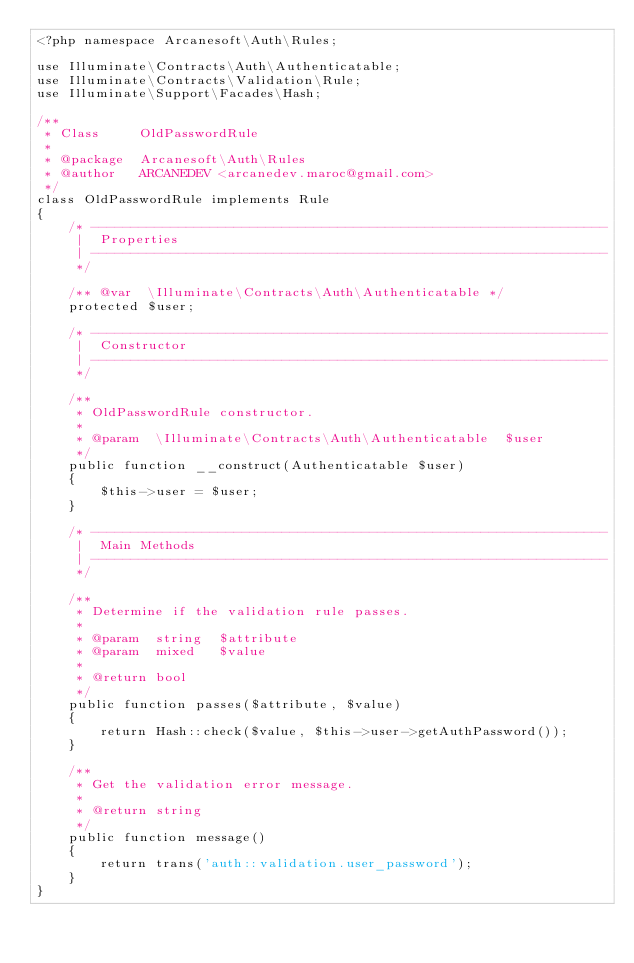<code> <loc_0><loc_0><loc_500><loc_500><_PHP_><?php namespace Arcanesoft\Auth\Rules;

use Illuminate\Contracts\Auth\Authenticatable;
use Illuminate\Contracts\Validation\Rule;
use Illuminate\Support\Facades\Hash;

/**
 * Class     OldPasswordRule
 *
 * @package  Arcanesoft\Auth\Rules
 * @author   ARCANEDEV <arcanedev.maroc@gmail.com>
 */
class OldPasswordRule implements Rule
{
    /* -----------------------------------------------------------------
     |  Properties
     | -----------------------------------------------------------------
     */

    /** @var  \Illuminate\Contracts\Auth\Authenticatable */
    protected $user;

    /* -----------------------------------------------------------------
     |  Constructor
     | -----------------------------------------------------------------
     */

    /**
     * OldPasswordRule constructor.
     *
     * @param  \Illuminate\Contracts\Auth\Authenticatable  $user
     */
    public function __construct(Authenticatable $user)
    {
        $this->user = $user;
    }

    /* -----------------------------------------------------------------
     |  Main Methods
     | -----------------------------------------------------------------
     */

    /**
     * Determine if the validation rule passes.
     *
     * @param  string  $attribute
     * @param  mixed   $value
     *
     * @return bool
     */
    public function passes($attribute, $value)
    {
        return Hash::check($value, $this->user->getAuthPassword());
    }

    /**
     * Get the validation error message.
     *
     * @return string
     */
    public function message()
    {
        return trans('auth::validation.user_password');
    }
}
</code> 